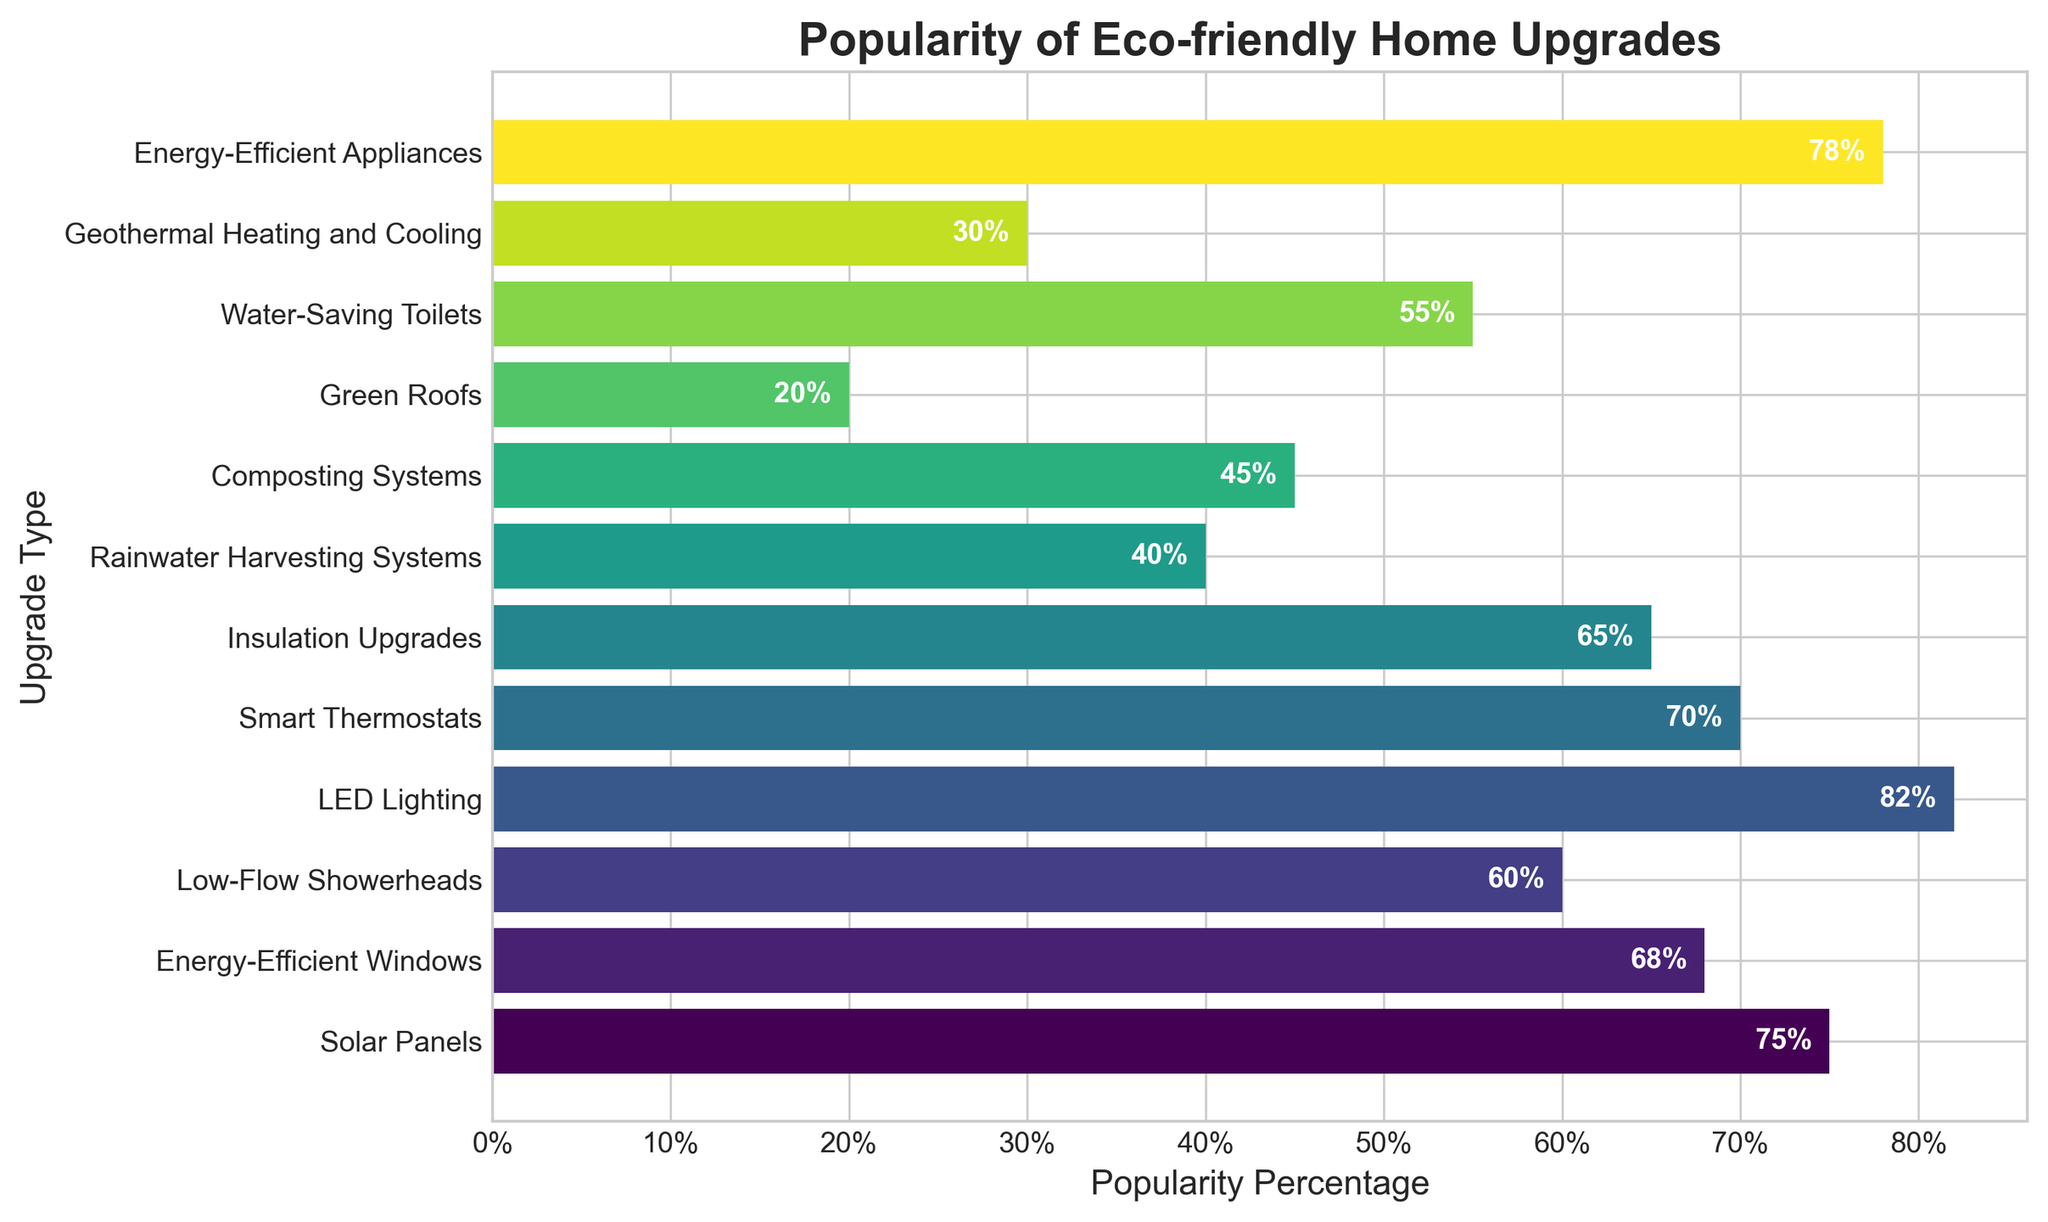Which eco-friendly home upgrade is the most popular? The bar chart shows the percentage popularity of various eco-friendly upgrades. The longest bar represents the most popular upgrade, which is LED Lighting at 82%.
Answer: LED Lighting Which eco-friendly home upgrade is the least popular? The shortest bar in the bar chart represents the least popular upgrade, which is Green Roofs at 20%.
Answer: Green Roofs What is the difference in popularity between Solar Panels and Green Roofs? The bar for Solar Panels shows 75%, and the bar for Green Roofs shows 20%. Subtract 20% from 75% to find the difference.
Answer: 55% Which upgrade is more popular: Smart Thermostats or Energy-Efficient Windows? The chart shows Smart Thermostats at 70% and Energy-Efficient Windows at 68%. Since 70% is greater than 68%, Smart Thermostats are more popular.
Answer: Smart Thermostats Are Insulation Upgrades more popular than Water-Saving Toilets? The bar chart shows Insulation Upgrades at 65% and Water-Saving Toilets at 55%. Since 65% is greater than 55%, Insulation Upgrades are more popular.
Answer: Yes What is the average popularity percentage of Solar Panels, Energy-Efficient Windows, and LED Lighting? The percentages are 75% (Solar Panels), 68% (Energy-Efficient Windows), and 82% (LED Lighting). Sum these percentages: 75 + 68 + 82 = 225. Divide by the number of upgrades: 225 / 3 = 75%.
Answer: 75% Which upgrades have a popularity percentage greater than 70%? The bar chart shows the popularity percentages. LED Lighting (82%), Energy-Efficient Appliances (78%), Solar Panels (75%), and Smart Thermostats (70%). Since 70% is included, all named upgrades meet this criterion.
Answer: LED Lighting, Energy-Efficient Appliances, Solar Panels, Smart Thermostats What is the total popularity percentage of Low-Flow Showerheads, Rainwater Harvesting Systems, and Composting Systems combined? The percentages are 60% (Low-Flow Showerheads), 40% (Rainwater Harvesting Systems), and 45% (Composting Systems). Sum these percentages: 60 + 40 + 45 = 145%.
Answer: 145% What is the median popularity percentage of all the upgrades listed? List the percentages in ascending order: 20%, 30%, 40%, 45%, 55%, 60%, 65%, 68%, 70%, 75%, 78%, 82%. With 12 data points, the median is the average of the 6th and 7th values: (60% + 65%) / 2 = 62.5%.
Answer: 62.5% Do Energy-Efficient Appliances have a higher or lower popularity than Solar Panels? The bar chart shows Energy-Efficient Appliances at 78% and Solar Panels at 75%. Since 78% is greater than 75%, Energy-Efficient Appliances have a higher popularity.
Answer: Higher 